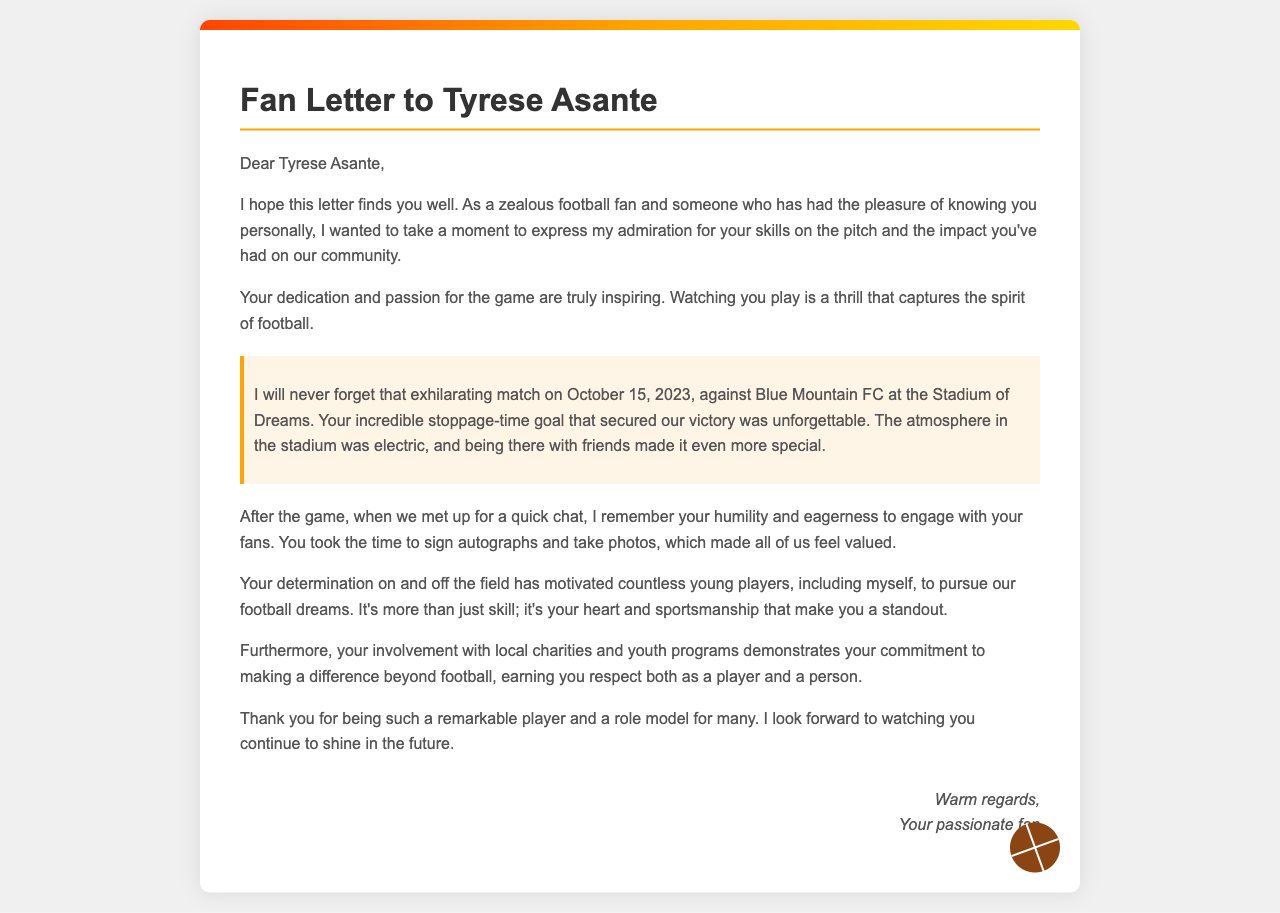what is the name of the player addressed in the letter? The letter is specifically addressed to Tyrese Asante, indicating admiration for him.
Answer: Tyrese Asante what was the date of the memorable match mentioned? The letter recounts a memorable match that took place on October 15, 2023.
Answer: October 15, 2023 which team did Tyrese Asante's team play against in the match? The letter states that the match was against Blue Mountain FC.
Answer: Blue Mountain FC what significant event did Tyrese Asante accomplish during the match? The letter highlights that he scored a stoppage-time goal that secured victory.
Answer: stoppage-time goal how did the author feel about Tyrese Asante's interaction with fans after the game? The author describes Tyrese's humility and eagerness to engage, feeling valued after he signed autographs.
Answer: valued what does the author express about Tyrese Asante's impact on young players? The author mentions that Tyrese's determination motivates countless young players to pursue their dreams.
Answer: motivates countless young players which element of Tyrese Asante's character is emphasized in the letter? The letter emphasizes his sportsmanship alongside his skill as a player.
Answer: sportsmanship what is the author's closing remark in the letter? The letter concludes with the author looking forward to watching Tyrese continue to shine in the future.
Answer: continue to shine 